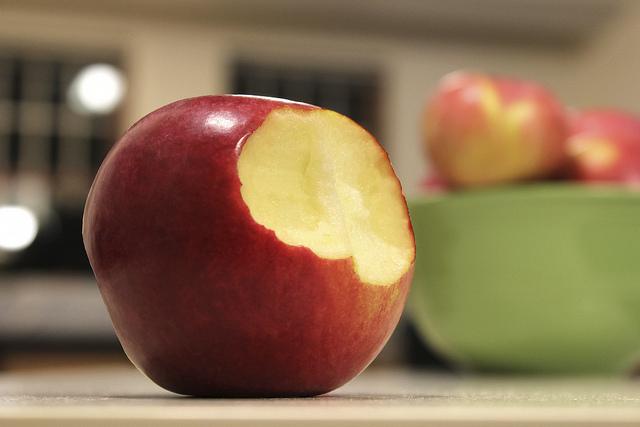How many apples are in the image?
Write a very short answer. 4. Is the apple bitten?
Write a very short answer. Yes. Where are the apples being placed?
Answer briefly. Bowl. 